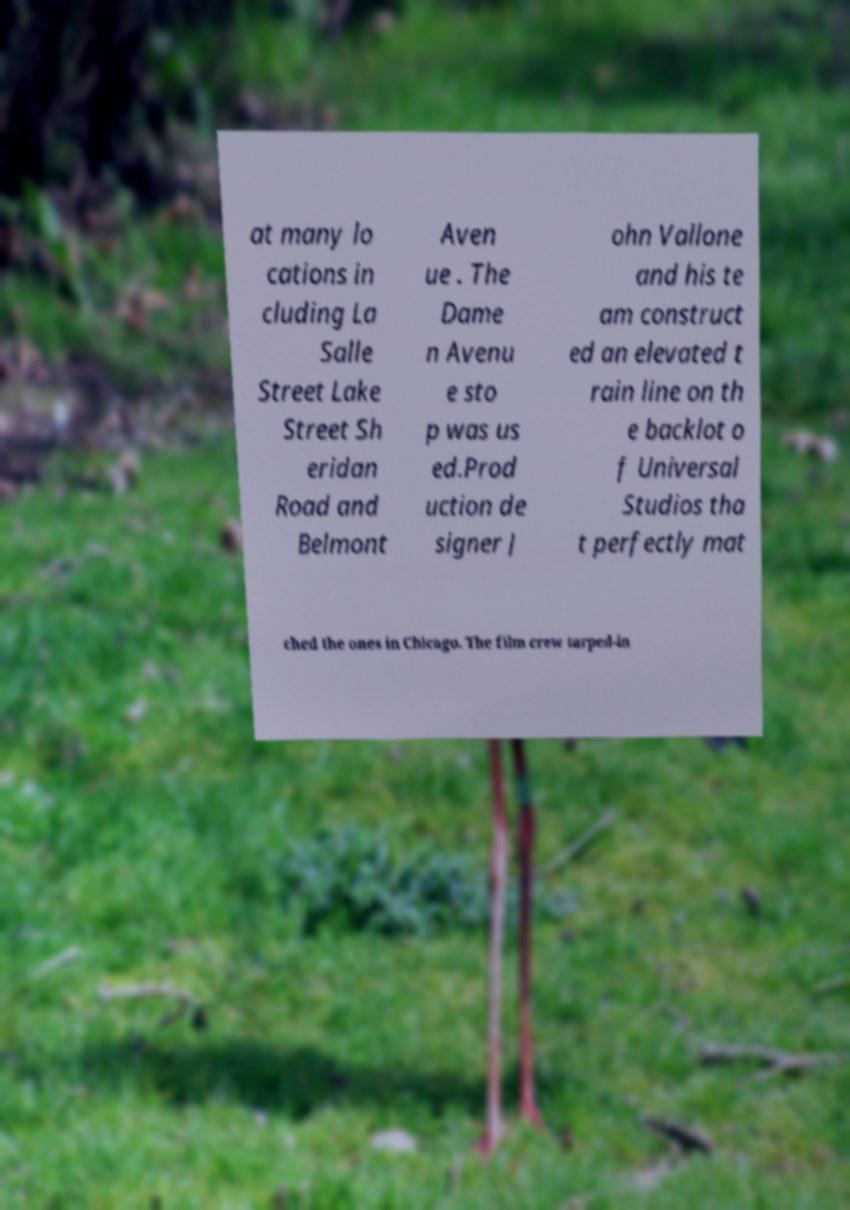Can you read and provide the text displayed in the image?This photo seems to have some interesting text. Can you extract and type it out for me? at many lo cations in cluding La Salle Street Lake Street Sh eridan Road and Belmont Aven ue . The Dame n Avenu e sto p was us ed.Prod uction de signer J ohn Vallone and his te am construct ed an elevated t rain line on th e backlot o f Universal Studios tha t perfectly mat ched the ones in Chicago. The film crew tarped-in 